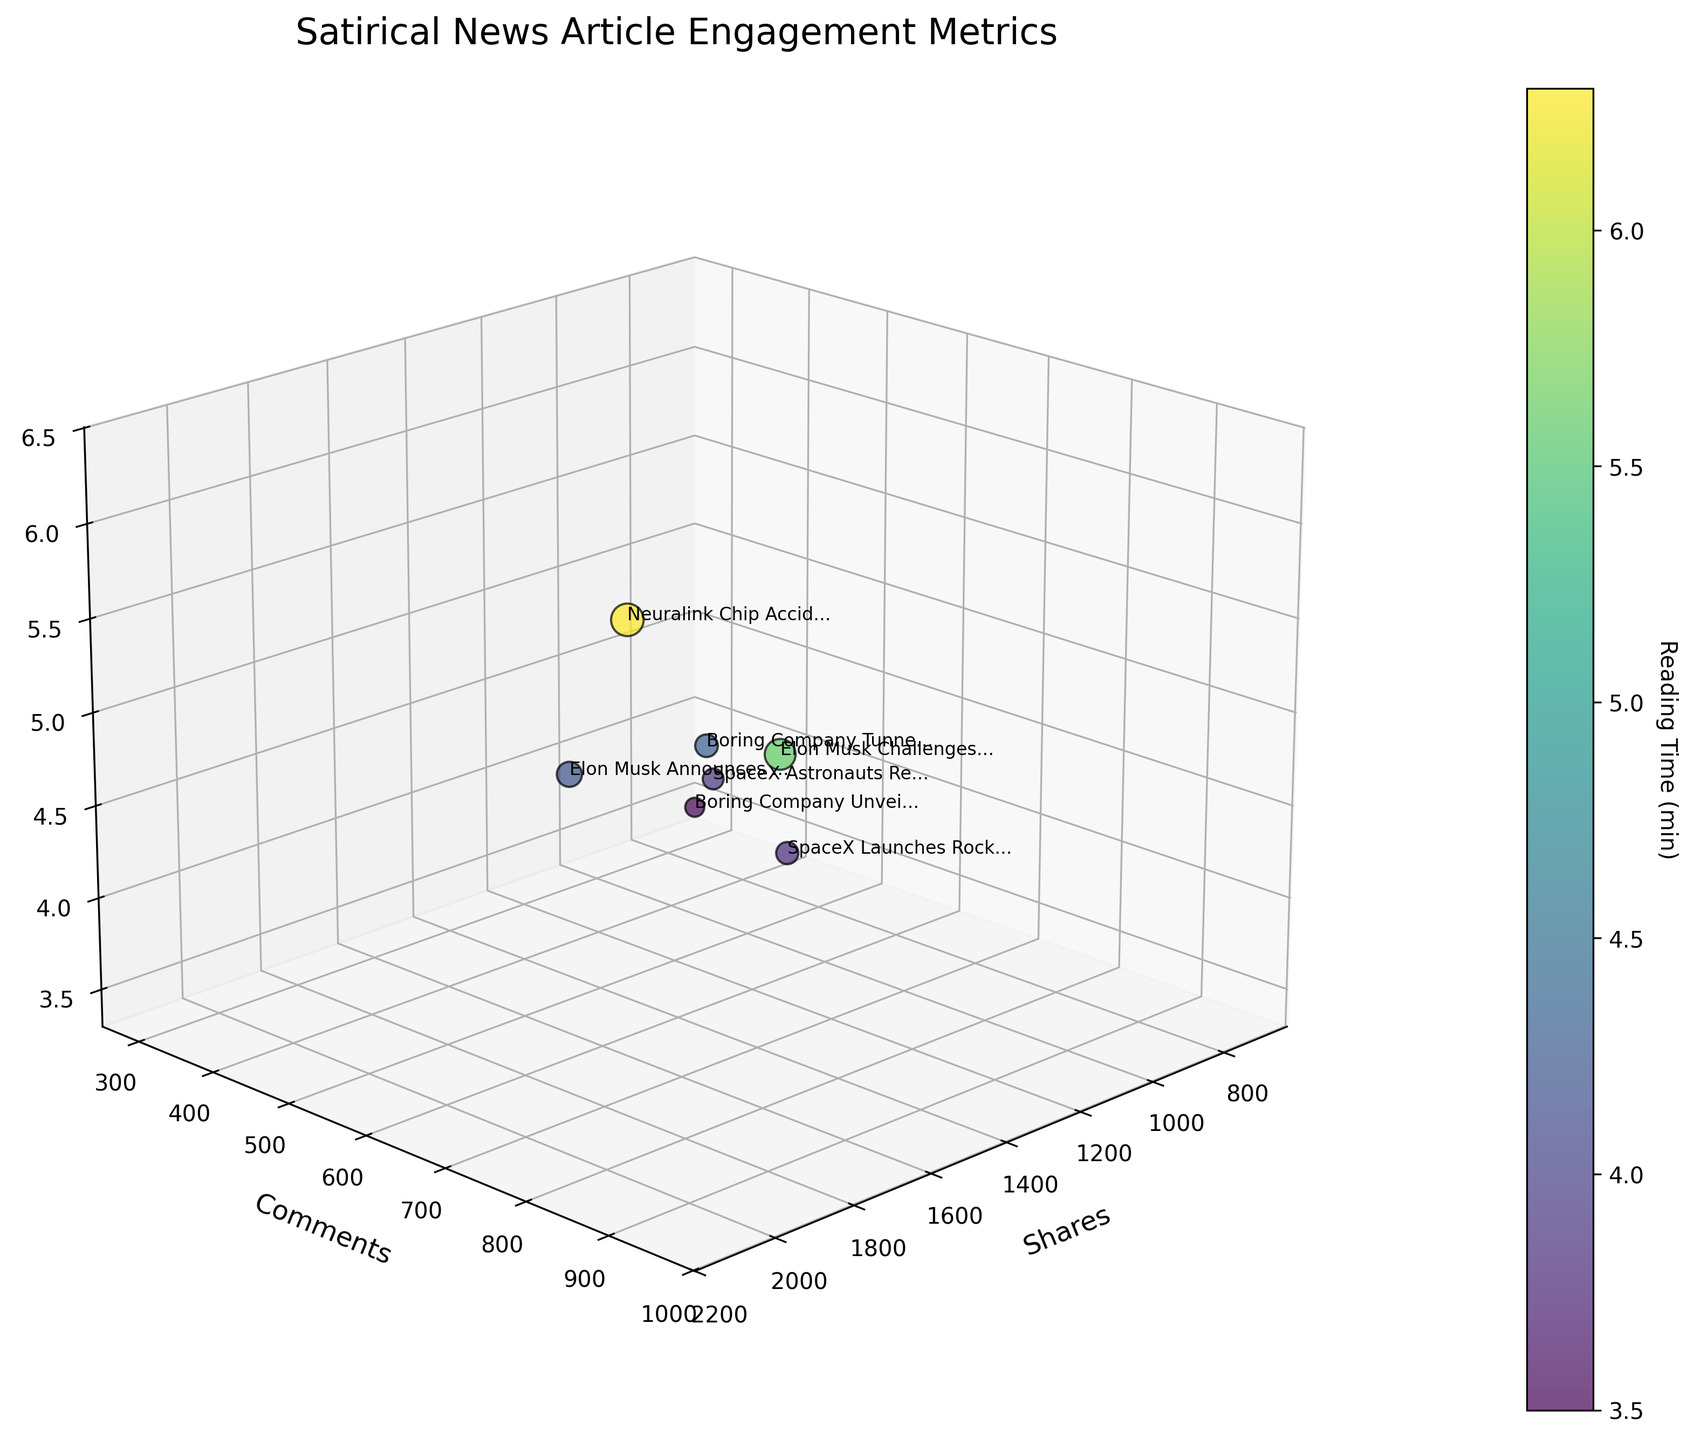What's the title of the 3D scatter plot? The title of a plot is usually displayed at the top. By looking at the top of the figure, you can find it.
Answer: Satirical News Article Engagement Metrics What are the labels for the axes? Axes labels are usually found next to each axis in a plot. By referring to these positions, you can see the labels "Shares", "Comments", and "Reading Time (min)".
Answer: Shares, Comments, Reading Time (min) How many data points are there in the plot? Each data point in a scatter plot represents an article. By counting the number of data points, you can find how many there are.
Answer: 7 Which article has the highest number of comments? The y-axis represents comments. The article with the highest y-value will have the most comments.
Answer: Elon Musk Challenges Mark Zuckerberg to 'Metaverse Duel' What's the range of reading times covered in the plot? The z-axis represents reading time. By observing the minimum and maximum values along the z-axis, you can find the range.
Answer: 3.5 to 6.3 minutes Which article has the least number of shares? The x-axis represents shares. The article with the smallest x-value will have the least shares.
Answer: Boring Company Unveils Underground Hyperloop for Snails How does the reading time change with the number of comments? By analyzing the z-axis (reading time) against the y-axis (comments), you can observe that higher reading times generally correspond to more comments as the data points with higher z-values are also higher along the y-axis.
Answer: Increases with more comments Are shares proportional to reading time? To determine proportionality, observe whether the trend line (an imagined line through the data points) for shares (x-axis) and reading time (z-axis) forms a consistent pattern. There's no clear linear trend indicating proportionality.
Answer: Not proportional What's the average number of comments for articles with over 1000 shares? First, identify articles with more than 1000 shares (x > 1000), then average their comment counts. The articles are "Elon Musk Announces Plan", "Neuralink Chip", and "Elon Musk Challenges", having comments 387, 876, and 954 respectively. The average is (387 + 876 + 954) / 3 = 739.
Answer: 739 Which article has the largest difference between shares and comments? Calculate the difference between shares and comments for each article. The article with the largest absolute value determines the answer. "Elon Musk Announces Plan" has the largest difference of 1250 shares - 387 comments = 863.
Answer: Elon Musk Announces Plan to Colonize Mars with Tesla Cybertruck Fleet 